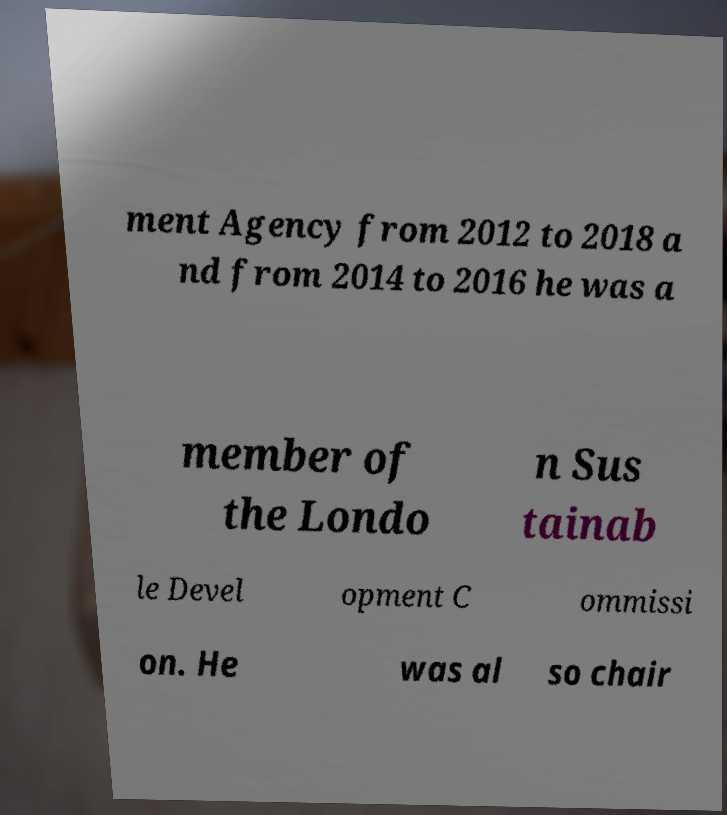Please read and relay the text visible in this image. What does it say? ment Agency from 2012 to 2018 a nd from 2014 to 2016 he was a member of the Londo n Sus tainab le Devel opment C ommissi on. He was al so chair 